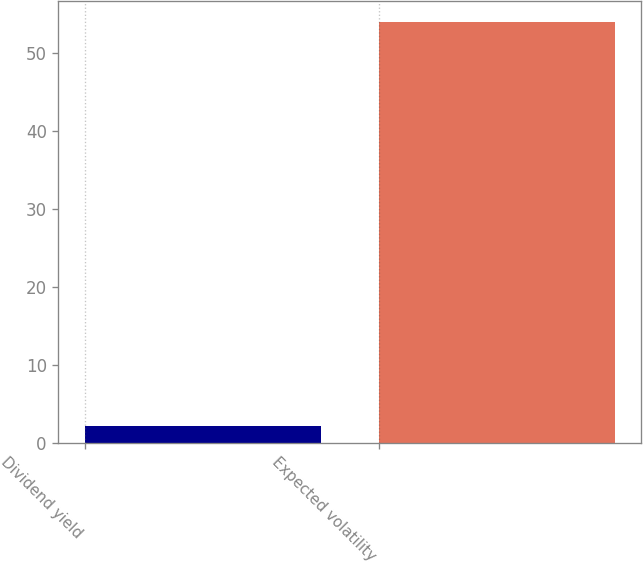Convert chart. <chart><loc_0><loc_0><loc_500><loc_500><bar_chart><fcel>Dividend yield<fcel>Expected volatility<nl><fcel>2.15<fcel>53.9<nl></chart> 